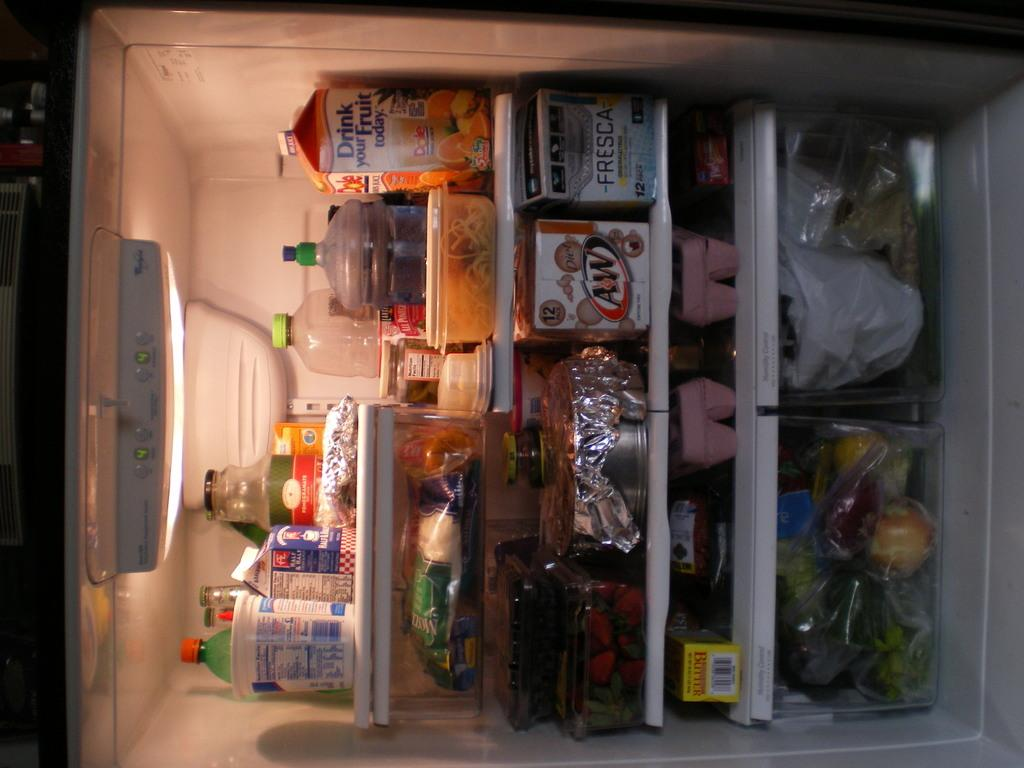<image>
Render a clear and concise summary of the photo. A packed open refrigerator with a&w diet soda, dole fruit juice, and other items 